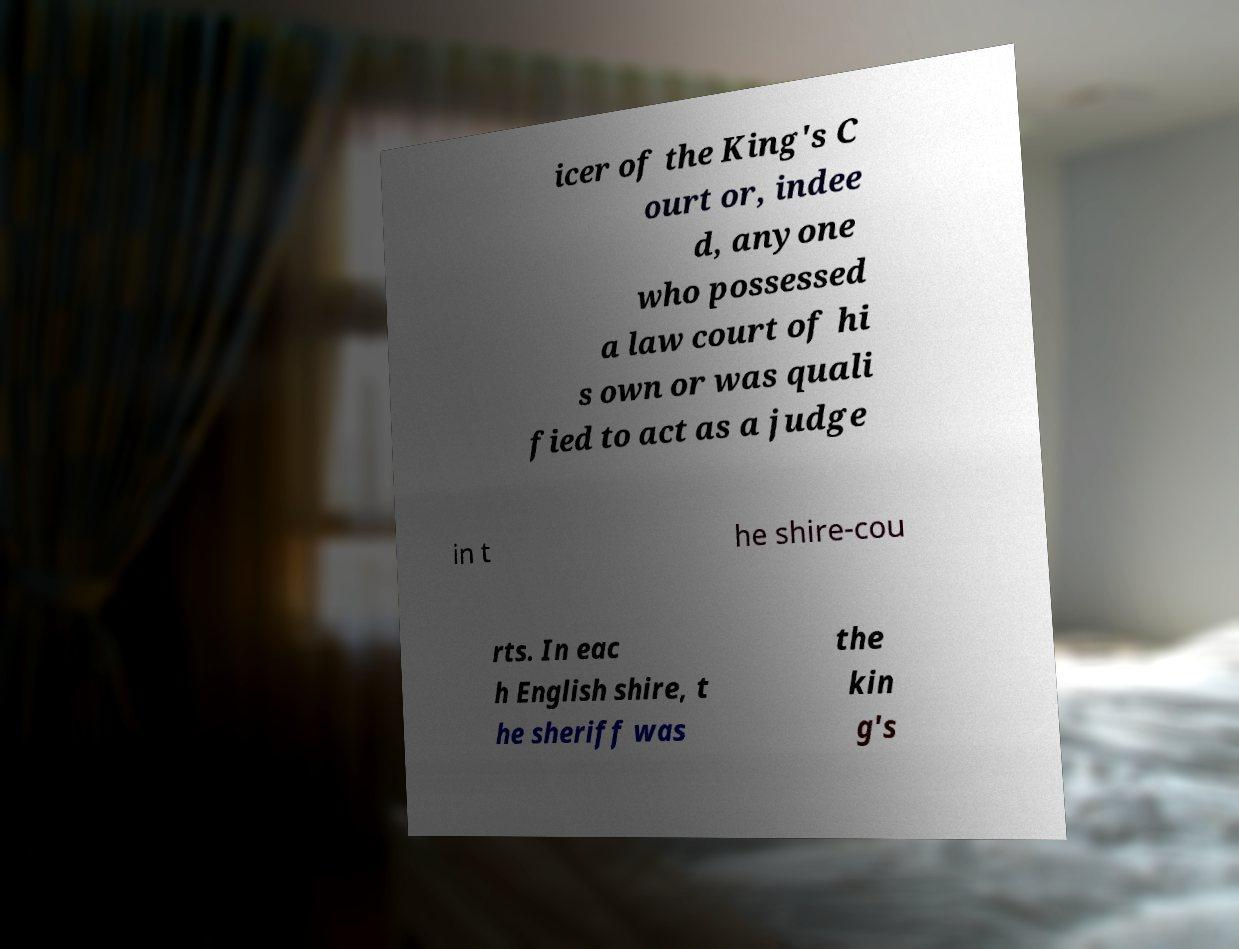Can you accurately transcribe the text from the provided image for me? icer of the King's C ourt or, indee d, anyone who possessed a law court of hi s own or was quali fied to act as a judge in t he shire-cou rts. In eac h English shire, t he sheriff was the kin g's 